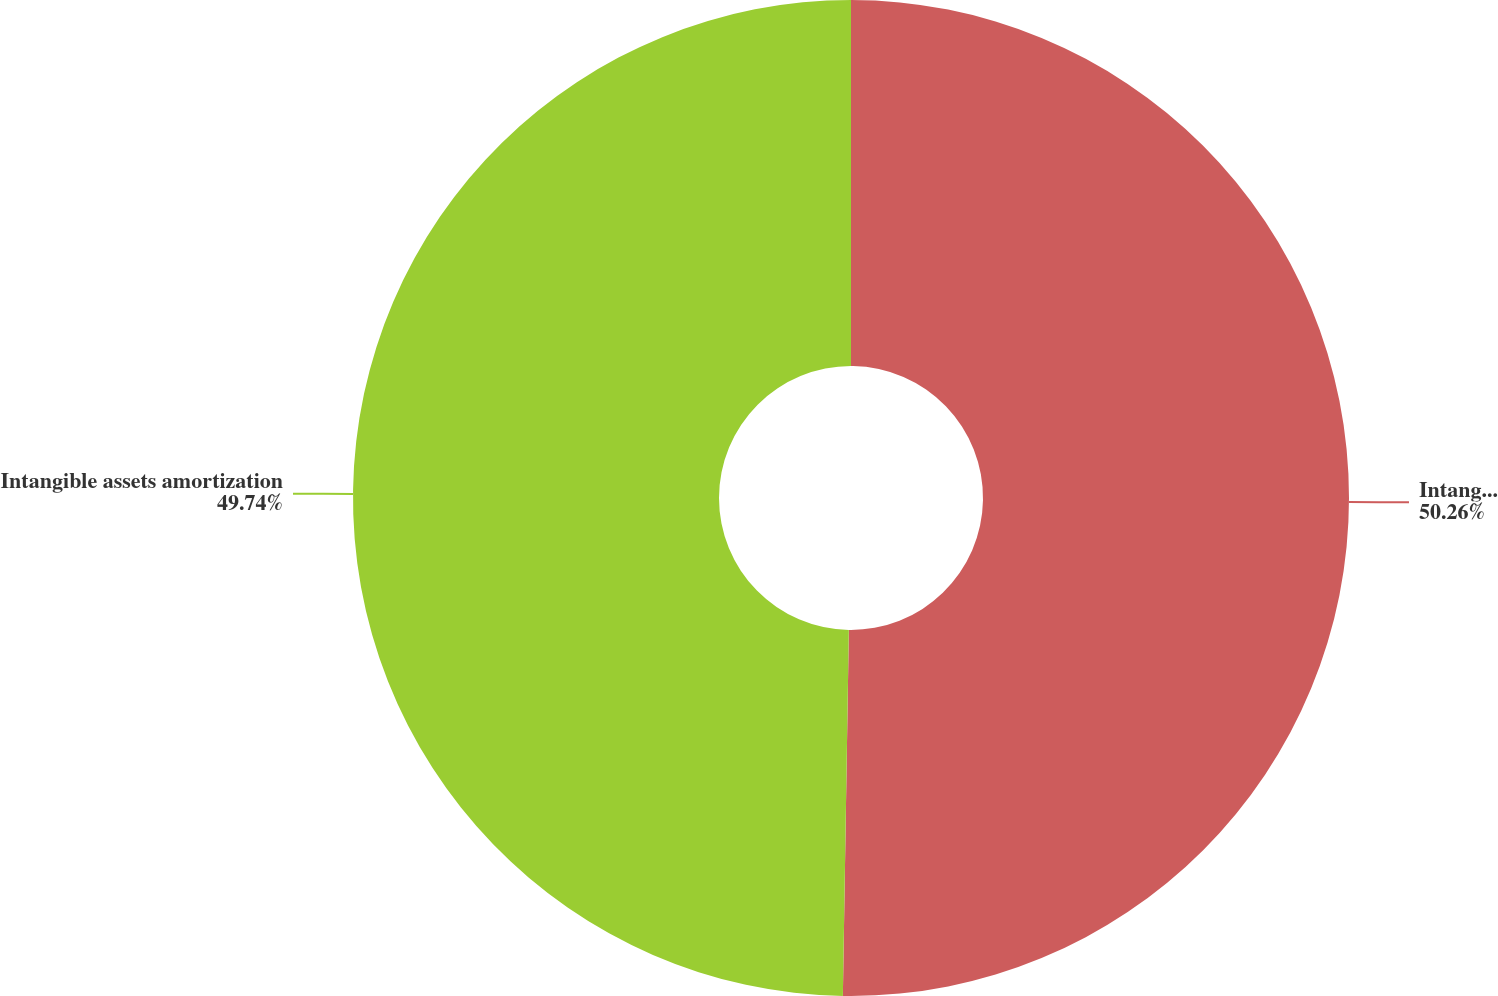Convert chart. <chart><loc_0><loc_0><loc_500><loc_500><pie_chart><fcel>Intangible asset amortization<fcel>Intangible assets amortization<nl><fcel>50.26%<fcel>49.74%<nl></chart> 